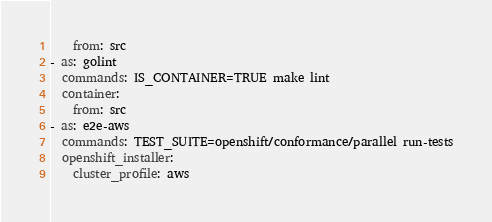<code> <loc_0><loc_0><loc_500><loc_500><_YAML_>    from: src
- as: golint
  commands: IS_CONTAINER=TRUE make lint
  container:
    from: src
- as: e2e-aws
  commands: TEST_SUITE=openshift/conformance/parallel run-tests
  openshift_installer:
    cluster_profile: aws
</code> 